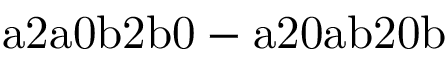<formula> <loc_0><loc_0><loc_500><loc_500>a 2 a 0 b 2 b 0 - a 2 0 a b 2 0 b</formula> 